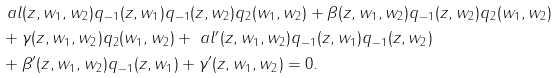<formula> <loc_0><loc_0><loc_500><loc_500>& \ a l ( z , w _ { 1 } , w _ { 2 } ) q _ { - 1 } ( z , w _ { 1 } ) q _ { - 1 } ( z , w _ { 2 } ) q _ { 2 } ( w _ { 1 } , w _ { 2 } ) + \beta ( z , w _ { 1 } , w _ { 2 } ) q _ { - 1 } ( z , w _ { 2 } ) q _ { 2 } ( w _ { 1 } , w _ { 2 } ) \\ & + \gamma ( z , w _ { 1 } , w _ { 2 } ) q _ { 2 } ( w _ { 1 } , w _ { 2 } ) + \ a l ^ { \prime } ( z , w _ { 1 } , w _ { 2 } ) q _ { - 1 } ( z , w _ { 1 } ) q _ { - 1 } ( z , w _ { 2 } ) \\ & + \beta ^ { \prime } ( z , w _ { 1 } , w _ { 2 } ) q _ { - 1 } ( z , w _ { 1 } ) + \gamma ^ { \prime } ( z , w _ { 1 } , w _ { 2 } ) = 0 .</formula> 